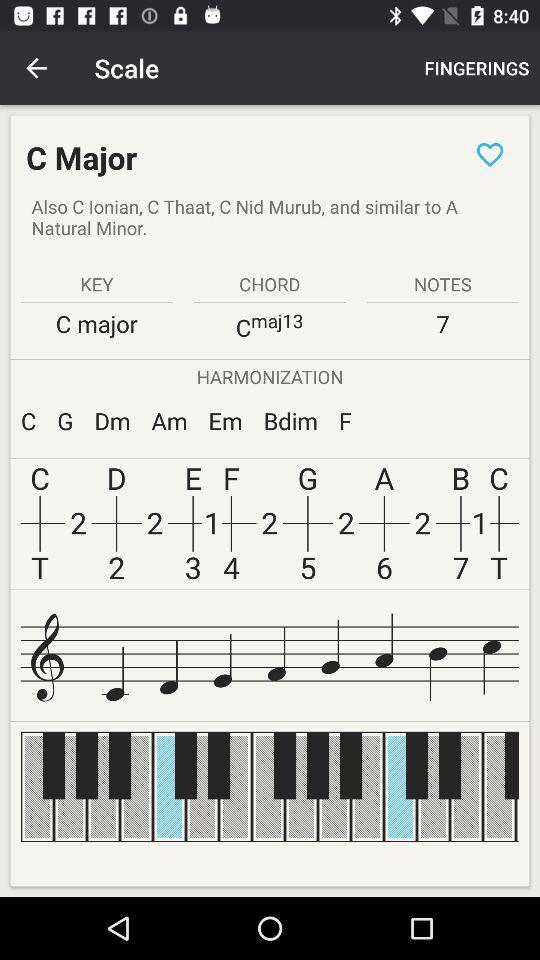What is the key? The key is "C major". 